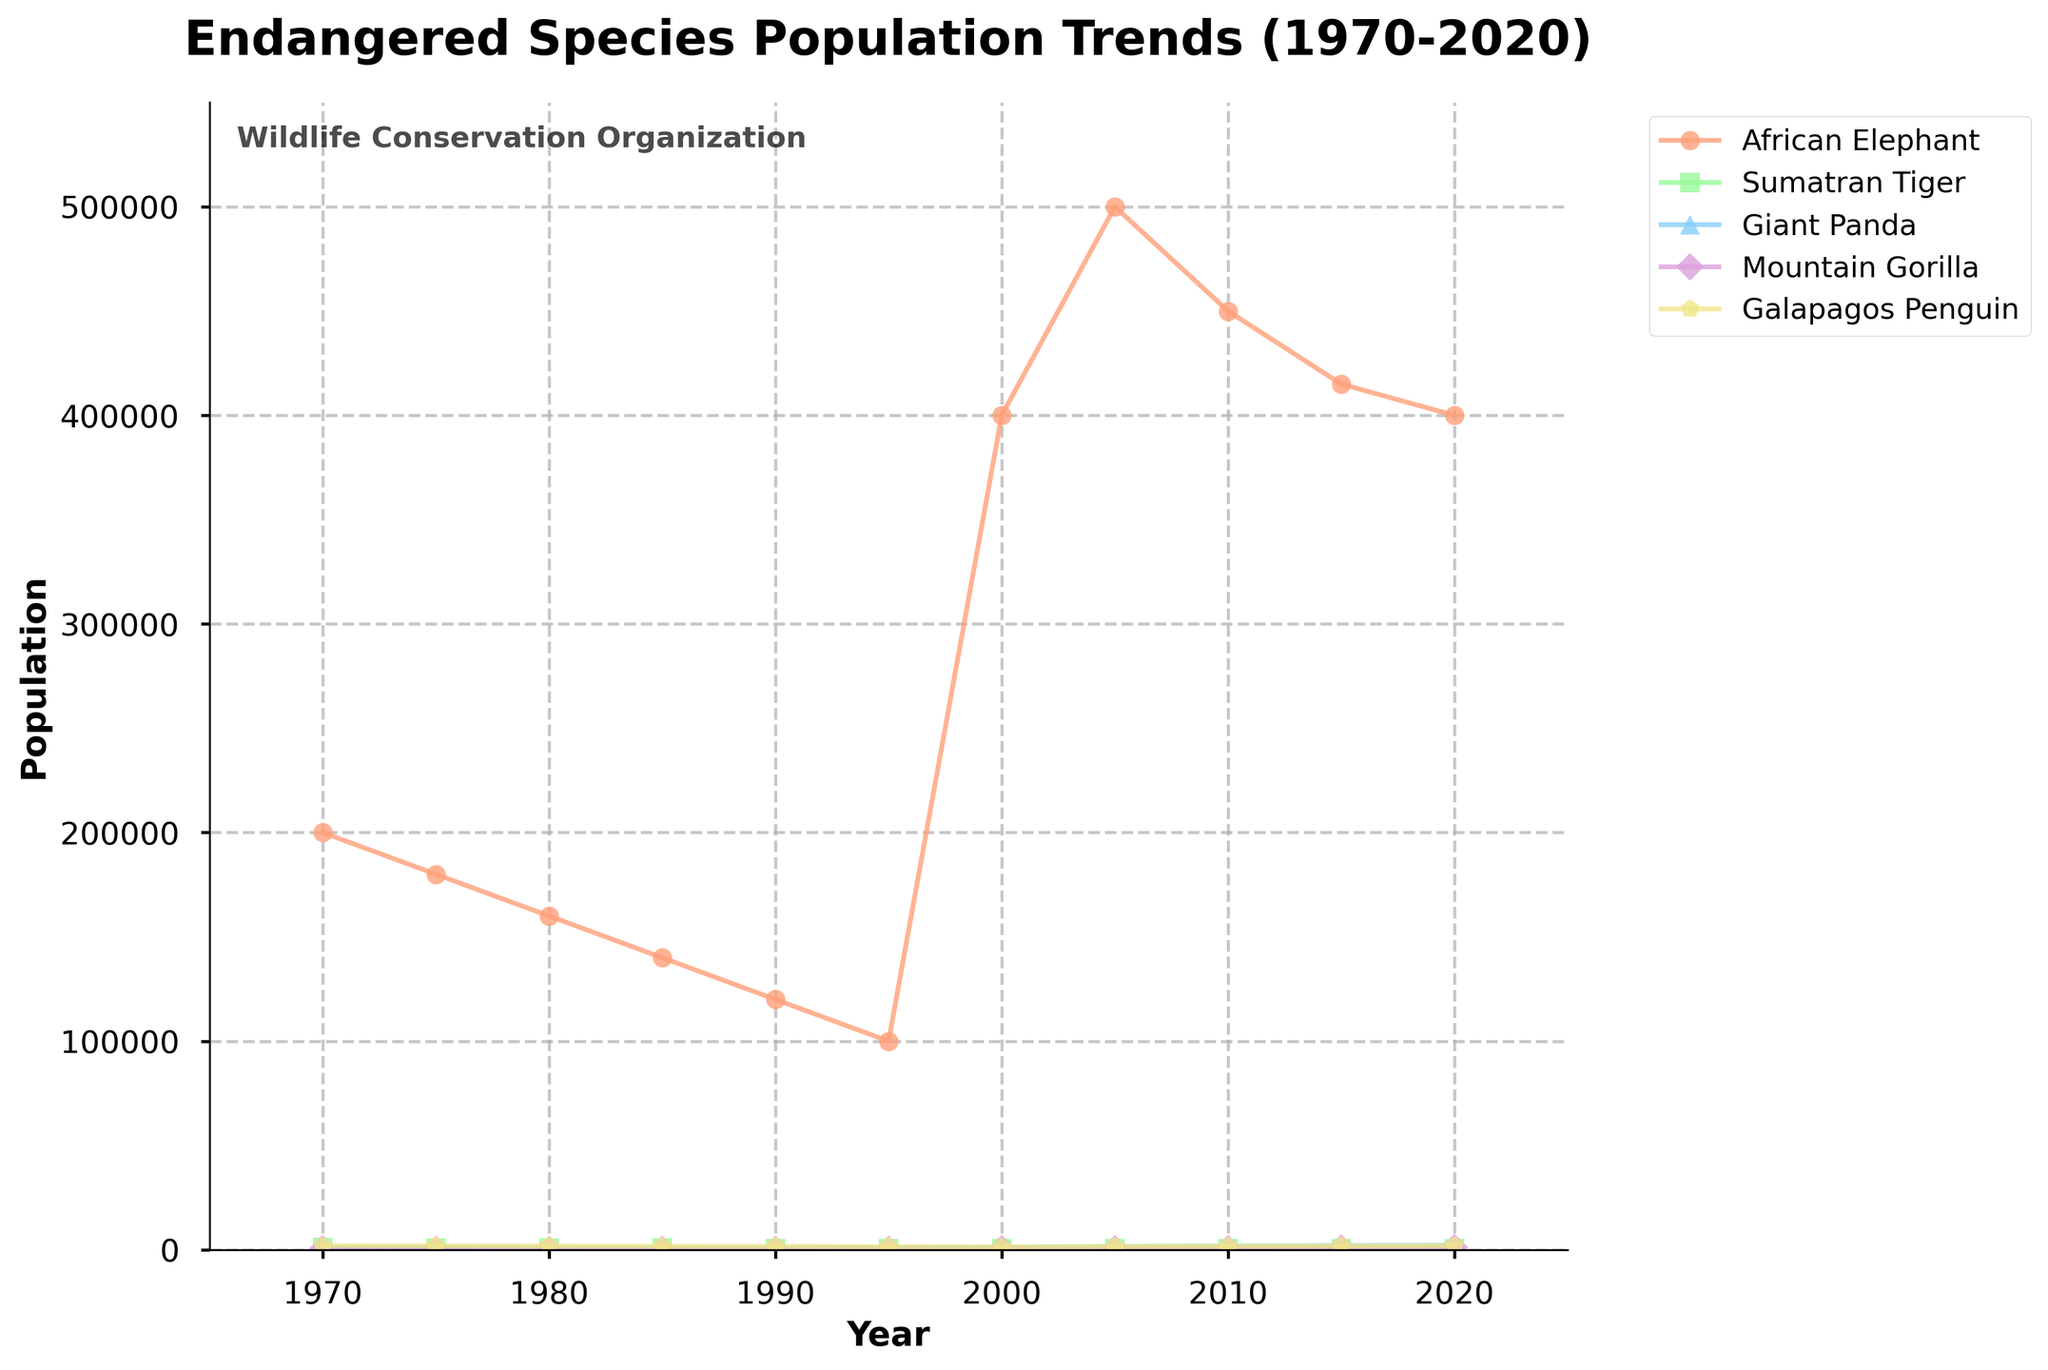What is the population trend of the Sumatran Tiger from 1970 to 2020? The Sumatran Tiger's population starts at 1000 in 1970 and decreases steadily until 1995, where it reaches 400. Then, its population starts to recover, increasing to 600 by 2020. This shows a decline followed by gradual recovery.
Answer: Decline then recovery Which species had the highest population in the year 2020? By examining the line chart, we see that the African Elephant's population is the highest in 2020, reaching 400,000.
Answer: African Elephant Between which years did the Giant Panda experience the most significant population increase? The Giant Panda population shows significant increases between 2000 (1200) and 2005 (1600), from 2005 to 2010 (1800), and from 2010 to 2015 (2000). The most significant single increase is between 2000 and 2005, where it increased by 400.
Answer: 2000 to 2005 How did the population of the Mountain Gorilla change from 1985 to 1990? The population of the Mountain Gorilla decreased from 1985 (250) to 1990 (320). Hence, it shows a decline in this particular period.
Answer: Decreased Which species shows a general upward population trend starting from around the year 2000? The populations for the species should be checked from the year 2000 onward. The African Elephant, Giant Panda, Mountain Gorilla, and Galapagos Penguin all show upward trends starting in 2000.
Answer: African Elephant, Giant Panda, Mountain Gorilla, Galapagos Penguin What is the difference in the population of African Elephants between 1970 and 2020? The population of African Elephants was 200,000 in 1970 and 400,000 in 2020. The difference between these two populations is 400,000 - 200,000 = 200,000.
Answer: 200,000 In which time period does the Galapagos Penguin show the least variability in population? From 1995 to 2020, the population of the Galapagos Penguin varies the least, maintaining a steady count around 1500 to 2000 without significant drops or spikes.
Answer: 1995 to 2020 Compare the populations of the Sumatran Tiger and the Mountain Gorilla in 2015. Which population is higher? The population of the Sumatran Tiger in 2015 is 550, whereas the population of the Mountain Gorilla is 880. Therefore, the Mountain Gorilla population is higher.
Answer: Mountain Gorilla What was the overall population trend for all species combined from 1970 to 2020? By adding up yearly changes, it's possible to observe that the total populations initially decline steeply until 1995 and then generally increase after that. The overall trend is an initial decline followed by a recovery phase.
Answer: Decline then recovery 